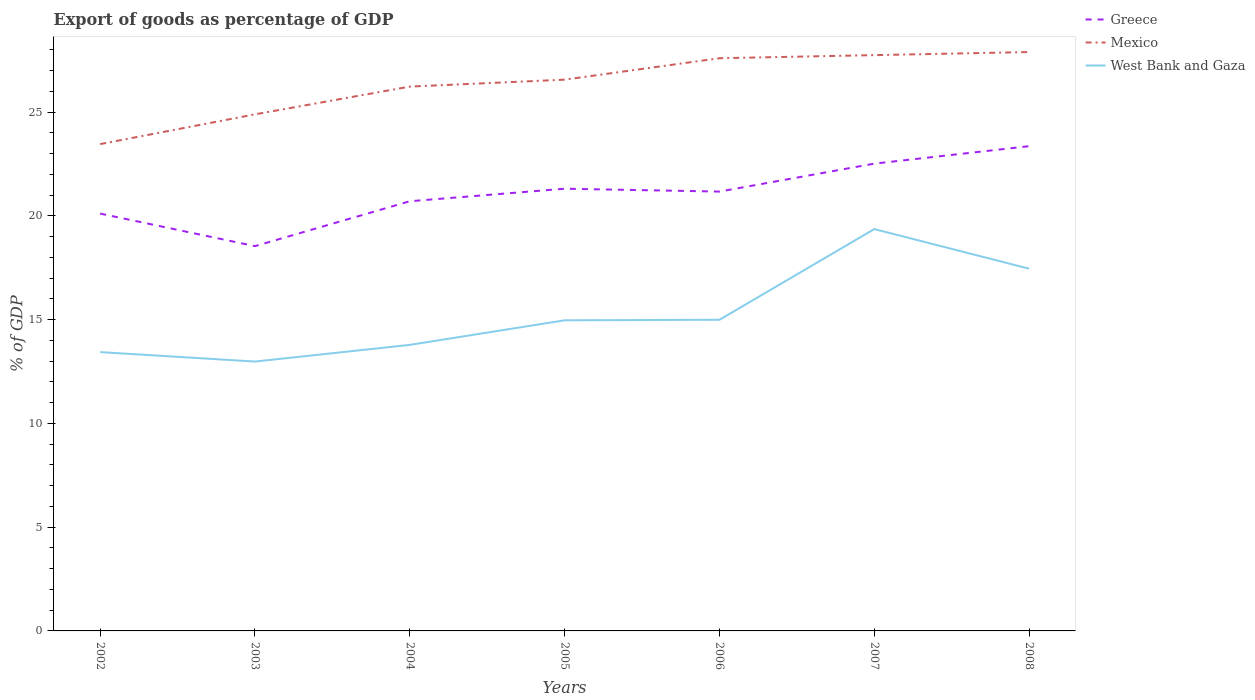How many different coloured lines are there?
Provide a succinct answer. 3. Does the line corresponding to Mexico intersect with the line corresponding to Greece?
Offer a very short reply. No. Is the number of lines equal to the number of legend labels?
Offer a terse response. Yes. Across all years, what is the maximum export of goods as percentage of GDP in Greece?
Your answer should be compact. 18.54. What is the total export of goods as percentage of GDP in Mexico in the graph?
Keep it short and to the point. -4.44. What is the difference between the highest and the second highest export of goods as percentage of GDP in Mexico?
Your answer should be very brief. 4.44. What is the difference between the highest and the lowest export of goods as percentage of GDP in West Bank and Gaza?
Offer a very short reply. 2. Is the export of goods as percentage of GDP in West Bank and Gaza strictly greater than the export of goods as percentage of GDP in Greece over the years?
Offer a terse response. Yes. How many lines are there?
Offer a terse response. 3. What is the difference between two consecutive major ticks on the Y-axis?
Provide a short and direct response. 5. How many legend labels are there?
Offer a terse response. 3. What is the title of the graph?
Your answer should be very brief. Export of goods as percentage of GDP. Does "Uganda" appear as one of the legend labels in the graph?
Make the answer very short. No. What is the label or title of the Y-axis?
Your answer should be very brief. % of GDP. What is the % of GDP in Greece in 2002?
Ensure brevity in your answer.  20.11. What is the % of GDP in Mexico in 2002?
Your response must be concise. 23.46. What is the % of GDP in West Bank and Gaza in 2002?
Your answer should be very brief. 13.44. What is the % of GDP of Greece in 2003?
Ensure brevity in your answer.  18.54. What is the % of GDP of Mexico in 2003?
Keep it short and to the point. 24.9. What is the % of GDP of West Bank and Gaza in 2003?
Ensure brevity in your answer.  12.98. What is the % of GDP of Greece in 2004?
Keep it short and to the point. 20.71. What is the % of GDP of Mexico in 2004?
Ensure brevity in your answer.  26.23. What is the % of GDP in West Bank and Gaza in 2004?
Provide a short and direct response. 13.79. What is the % of GDP in Greece in 2005?
Keep it short and to the point. 21.31. What is the % of GDP in Mexico in 2005?
Keep it short and to the point. 26.57. What is the % of GDP of West Bank and Gaza in 2005?
Offer a very short reply. 14.97. What is the % of GDP of Greece in 2006?
Offer a very short reply. 21.17. What is the % of GDP in Mexico in 2006?
Your response must be concise. 27.6. What is the % of GDP in West Bank and Gaza in 2006?
Provide a short and direct response. 15. What is the % of GDP of Greece in 2007?
Provide a short and direct response. 22.52. What is the % of GDP of Mexico in 2007?
Make the answer very short. 27.75. What is the % of GDP in West Bank and Gaza in 2007?
Your answer should be compact. 19.37. What is the % of GDP of Greece in 2008?
Your response must be concise. 23.36. What is the % of GDP of Mexico in 2008?
Your response must be concise. 27.9. What is the % of GDP of West Bank and Gaza in 2008?
Your answer should be very brief. 17.46. Across all years, what is the maximum % of GDP of Greece?
Keep it short and to the point. 23.36. Across all years, what is the maximum % of GDP of Mexico?
Your answer should be very brief. 27.9. Across all years, what is the maximum % of GDP of West Bank and Gaza?
Your answer should be compact. 19.37. Across all years, what is the minimum % of GDP in Greece?
Your response must be concise. 18.54. Across all years, what is the minimum % of GDP in Mexico?
Provide a short and direct response. 23.46. Across all years, what is the minimum % of GDP of West Bank and Gaza?
Make the answer very short. 12.98. What is the total % of GDP in Greece in the graph?
Your response must be concise. 147.73. What is the total % of GDP in Mexico in the graph?
Give a very brief answer. 184.41. What is the total % of GDP of West Bank and Gaza in the graph?
Your response must be concise. 106.99. What is the difference between the % of GDP of Greece in 2002 and that in 2003?
Provide a succinct answer. 1.57. What is the difference between the % of GDP in Mexico in 2002 and that in 2003?
Your response must be concise. -1.43. What is the difference between the % of GDP of West Bank and Gaza in 2002 and that in 2003?
Offer a terse response. 0.46. What is the difference between the % of GDP in Greece in 2002 and that in 2004?
Make the answer very short. -0.6. What is the difference between the % of GDP of Mexico in 2002 and that in 2004?
Make the answer very short. -2.77. What is the difference between the % of GDP in West Bank and Gaza in 2002 and that in 2004?
Ensure brevity in your answer.  -0.35. What is the difference between the % of GDP in Greece in 2002 and that in 2005?
Your response must be concise. -1.2. What is the difference between the % of GDP of Mexico in 2002 and that in 2005?
Your answer should be compact. -3.11. What is the difference between the % of GDP in West Bank and Gaza in 2002 and that in 2005?
Keep it short and to the point. -1.53. What is the difference between the % of GDP in Greece in 2002 and that in 2006?
Your response must be concise. -1.06. What is the difference between the % of GDP of Mexico in 2002 and that in 2006?
Offer a terse response. -4.14. What is the difference between the % of GDP of West Bank and Gaza in 2002 and that in 2006?
Keep it short and to the point. -1.56. What is the difference between the % of GDP in Greece in 2002 and that in 2007?
Offer a very short reply. -2.41. What is the difference between the % of GDP in Mexico in 2002 and that in 2007?
Make the answer very short. -4.29. What is the difference between the % of GDP of West Bank and Gaza in 2002 and that in 2007?
Provide a succinct answer. -5.93. What is the difference between the % of GDP of Greece in 2002 and that in 2008?
Make the answer very short. -3.25. What is the difference between the % of GDP in Mexico in 2002 and that in 2008?
Your answer should be compact. -4.44. What is the difference between the % of GDP of West Bank and Gaza in 2002 and that in 2008?
Provide a succinct answer. -4.02. What is the difference between the % of GDP of Greece in 2003 and that in 2004?
Keep it short and to the point. -2.16. What is the difference between the % of GDP in Mexico in 2003 and that in 2004?
Provide a succinct answer. -1.34. What is the difference between the % of GDP of West Bank and Gaza in 2003 and that in 2004?
Provide a short and direct response. -0.8. What is the difference between the % of GDP in Greece in 2003 and that in 2005?
Ensure brevity in your answer.  -2.77. What is the difference between the % of GDP in Mexico in 2003 and that in 2005?
Make the answer very short. -1.67. What is the difference between the % of GDP of West Bank and Gaza in 2003 and that in 2005?
Make the answer very short. -1.99. What is the difference between the % of GDP in Greece in 2003 and that in 2006?
Provide a short and direct response. -2.63. What is the difference between the % of GDP in Mexico in 2003 and that in 2006?
Keep it short and to the point. -2.7. What is the difference between the % of GDP of West Bank and Gaza in 2003 and that in 2006?
Keep it short and to the point. -2.01. What is the difference between the % of GDP of Greece in 2003 and that in 2007?
Give a very brief answer. -3.98. What is the difference between the % of GDP of Mexico in 2003 and that in 2007?
Ensure brevity in your answer.  -2.85. What is the difference between the % of GDP of West Bank and Gaza in 2003 and that in 2007?
Offer a very short reply. -6.39. What is the difference between the % of GDP in Greece in 2003 and that in 2008?
Give a very brief answer. -4.82. What is the difference between the % of GDP of Mexico in 2003 and that in 2008?
Make the answer very short. -3. What is the difference between the % of GDP of West Bank and Gaza in 2003 and that in 2008?
Your answer should be compact. -4.48. What is the difference between the % of GDP of Greece in 2004 and that in 2005?
Your answer should be compact. -0.6. What is the difference between the % of GDP in Mexico in 2004 and that in 2005?
Your answer should be compact. -0.33. What is the difference between the % of GDP in West Bank and Gaza in 2004 and that in 2005?
Your answer should be very brief. -1.18. What is the difference between the % of GDP of Greece in 2004 and that in 2006?
Offer a very short reply. -0.47. What is the difference between the % of GDP of Mexico in 2004 and that in 2006?
Make the answer very short. -1.37. What is the difference between the % of GDP in West Bank and Gaza in 2004 and that in 2006?
Your answer should be very brief. -1.21. What is the difference between the % of GDP of Greece in 2004 and that in 2007?
Offer a very short reply. -1.81. What is the difference between the % of GDP in Mexico in 2004 and that in 2007?
Provide a succinct answer. -1.52. What is the difference between the % of GDP in West Bank and Gaza in 2004 and that in 2007?
Provide a short and direct response. -5.58. What is the difference between the % of GDP of Greece in 2004 and that in 2008?
Make the answer very short. -2.65. What is the difference between the % of GDP of Mexico in 2004 and that in 2008?
Offer a terse response. -1.66. What is the difference between the % of GDP in West Bank and Gaza in 2004 and that in 2008?
Keep it short and to the point. -3.67. What is the difference between the % of GDP of Greece in 2005 and that in 2006?
Your response must be concise. 0.14. What is the difference between the % of GDP in Mexico in 2005 and that in 2006?
Provide a succinct answer. -1.03. What is the difference between the % of GDP in West Bank and Gaza in 2005 and that in 2006?
Your response must be concise. -0.03. What is the difference between the % of GDP of Greece in 2005 and that in 2007?
Your answer should be very brief. -1.21. What is the difference between the % of GDP in Mexico in 2005 and that in 2007?
Provide a short and direct response. -1.18. What is the difference between the % of GDP of West Bank and Gaza in 2005 and that in 2007?
Keep it short and to the point. -4.4. What is the difference between the % of GDP in Greece in 2005 and that in 2008?
Offer a terse response. -2.05. What is the difference between the % of GDP in Mexico in 2005 and that in 2008?
Provide a succinct answer. -1.33. What is the difference between the % of GDP of West Bank and Gaza in 2005 and that in 2008?
Provide a short and direct response. -2.49. What is the difference between the % of GDP in Greece in 2006 and that in 2007?
Keep it short and to the point. -1.35. What is the difference between the % of GDP in Mexico in 2006 and that in 2007?
Make the answer very short. -0.15. What is the difference between the % of GDP of West Bank and Gaza in 2006 and that in 2007?
Your answer should be compact. -4.37. What is the difference between the % of GDP in Greece in 2006 and that in 2008?
Keep it short and to the point. -2.19. What is the difference between the % of GDP of Mexico in 2006 and that in 2008?
Ensure brevity in your answer.  -0.3. What is the difference between the % of GDP in West Bank and Gaza in 2006 and that in 2008?
Your response must be concise. -2.46. What is the difference between the % of GDP in Greece in 2007 and that in 2008?
Your answer should be very brief. -0.84. What is the difference between the % of GDP in Mexico in 2007 and that in 2008?
Give a very brief answer. -0.15. What is the difference between the % of GDP in West Bank and Gaza in 2007 and that in 2008?
Provide a short and direct response. 1.91. What is the difference between the % of GDP in Greece in 2002 and the % of GDP in Mexico in 2003?
Ensure brevity in your answer.  -4.78. What is the difference between the % of GDP in Greece in 2002 and the % of GDP in West Bank and Gaza in 2003?
Your answer should be very brief. 7.13. What is the difference between the % of GDP of Mexico in 2002 and the % of GDP of West Bank and Gaza in 2003?
Make the answer very short. 10.48. What is the difference between the % of GDP in Greece in 2002 and the % of GDP in Mexico in 2004?
Keep it short and to the point. -6.12. What is the difference between the % of GDP of Greece in 2002 and the % of GDP of West Bank and Gaza in 2004?
Offer a terse response. 6.33. What is the difference between the % of GDP of Mexico in 2002 and the % of GDP of West Bank and Gaza in 2004?
Provide a succinct answer. 9.68. What is the difference between the % of GDP of Greece in 2002 and the % of GDP of Mexico in 2005?
Your response must be concise. -6.45. What is the difference between the % of GDP in Greece in 2002 and the % of GDP in West Bank and Gaza in 2005?
Offer a very short reply. 5.14. What is the difference between the % of GDP in Mexico in 2002 and the % of GDP in West Bank and Gaza in 2005?
Make the answer very short. 8.49. What is the difference between the % of GDP in Greece in 2002 and the % of GDP in Mexico in 2006?
Your response must be concise. -7.49. What is the difference between the % of GDP of Greece in 2002 and the % of GDP of West Bank and Gaza in 2006?
Ensure brevity in your answer.  5.12. What is the difference between the % of GDP of Mexico in 2002 and the % of GDP of West Bank and Gaza in 2006?
Your answer should be compact. 8.47. What is the difference between the % of GDP in Greece in 2002 and the % of GDP in Mexico in 2007?
Your response must be concise. -7.64. What is the difference between the % of GDP of Greece in 2002 and the % of GDP of West Bank and Gaza in 2007?
Your response must be concise. 0.75. What is the difference between the % of GDP of Mexico in 2002 and the % of GDP of West Bank and Gaza in 2007?
Provide a succinct answer. 4.1. What is the difference between the % of GDP of Greece in 2002 and the % of GDP of Mexico in 2008?
Provide a short and direct response. -7.79. What is the difference between the % of GDP in Greece in 2002 and the % of GDP in West Bank and Gaza in 2008?
Ensure brevity in your answer.  2.66. What is the difference between the % of GDP of Mexico in 2002 and the % of GDP of West Bank and Gaza in 2008?
Provide a succinct answer. 6.01. What is the difference between the % of GDP in Greece in 2003 and the % of GDP in Mexico in 2004?
Your response must be concise. -7.69. What is the difference between the % of GDP of Greece in 2003 and the % of GDP of West Bank and Gaza in 2004?
Provide a short and direct response. 4.76. What is the difference between the % of GDP of Mexico in 2003 and the % of GDP of West Bank and Gaza in 2004?
Make the answer very short. 11.11. What is the difference between the % of GDP in Greece in 2003 and the % of GDP in Mexico in 2005?
Your response must be concise. -8.02. What is the difference between the % of GDP in Greece in 2003 and the % of GDP in West Bank and Gaza in 2005?
Make the answer very short. 3.58. What is the difference between the % of GDP of Mexico in 2003 and the % of GDP of West Bank and Gaza in 2005?
Your answer should be compact. 9.93. What is the difference between the % of GDP in Greece in 2003 and the % of GDP in Mexico in 2006?
Make the answer very short. -9.06. What is the difference between the % of GDP in Greece in 2003 and the % of GDP in West Bank and Gaza in 2006?
Provide a succinct answer. 3.55. What is the difference between the % of GDP of Mexico in 2003 and the % of GDP of West Bank and Gaza in 2006?
Offer a terse response. 9.9. What is the difference between the % of GDP of Greece in 2003 and the % of GDP of Mexico in 2007?
Keep it short and to the point. -9.21. What is the difference between the % of GDP in Greece in 2003 and the % of GDP in West Bank and Gaza in 2007?
Keep it short and to the point. -0.82. What is the difference between the % of GDP in Mexico in 2003 and the % of GDP in West Bank and Gaza in 2007?
Ensure brevity in your answer.  5.53. What is the difference between the % of GDP of Greece in 2003 and the % of GDP of Mexico in 2008?
Offer a very short reply. -9.35. What is the difference between the % of GDP in Greece in 2003 and the % of GDP in West Bank and Gaza in 2008?
Your answer should be compact. 1.09. What is the difference between the % of GDP in Mexico in 2003 and the % of GDP in West Bank and Gaza in 2008?
Make the answer very short. 7.44. What is the difference between the % of GDP of Greece in 2004 and the % of GDP of Mexico in 2005?
Give a very brief answer. -5.86. What is the difference between the % of GDP in Greece in 2004 and the % of GDP in West Bank and Gaza in 2005?
Keep it short and to the point. 5.74. What is the difference between the % of GDP of Mexico in 2004 and the % of GDP of West Bank and Gaza in 2005?
Offer a terse response. 11.26. What is the difference between the % of GDP in Greece in 2004 and the % of GDP in Mexico in 2006?
Your response must be concise. -6.89. What is the difference between the % of GDP in Greece in 2004 and the % of GDP in West Bank and Gaza in 2006?
Provide a succinct answer. 5.71. What is the difference between the % of GDP in Mexico in 2004 and the % of GDP in West Bank and Gaza in 2006?
Ensure brevity in your answer.  11.24. What is the difference between the % of GDP of Greece in 2004 and the % of GDP of Mexico in 2007?
Make the answer very short. -7.04. What is the difference between the % of GDP of Greece in 2004 and the % of GDP of West Bank and Gaza in 2007?
Provide a short and direct response. 1.34. What is the difference between the % of GDP of Mexico in 2004 and the % of GDP of West Bank and Gaza in 2007?
Offer a terse response. 6.87. What is the difference between the % of GDP of Greece in 2004 and the % of GDP of Mexico in 2008?
Ensure brevity in your answer.  -7.19. What is the difference between the % of GDP in Greece in 2004 and the % of GDP in West Bank and Gaza in 2008?
Keep it short and to the point. 3.25. What is the difference between the % of GDP of Mexico in 2004 and the % of GDP of West Bank and Gaza in 2008?
Your answer should be compact. 8.78. What is the difference between the % of GDP in Greece in 2005 and the % of GDP in Mexico in 2006?
Offer a very short reply. -6.29. What is the difference between the % of GDP in Greece in 2005 and the % of GDP in West Bank and Gaza in 2006?
Ensure brevity in your answer.  6.32. What is the difference between the % of GDP in Mexico in 2005 and the % of GDP in West Bank and Gaza in 2006?
Your answer should be very brief. 11.57. What is the difference between the % of GDP of Greece in 2005 and the % of GDP of Mexico in 2007?
Keep it short and to the point. -6.44. What is the difference between the % of GDP of Greece in 2005 and the % of GDP of West Bank and Gaza in 2007?
Offer a very short reply. 1.95. What is the difference between the % of GDP in Mexico in 2005 and the % of GDP in West Bank and Gaza in 2007?
Ensure brevity in your answer.  7.2. What is the difference between the % of GDP in Greece in 2005 and the % of GDP in Mexico in 2008?
Offer a very short reply. -6.59. What is the difference between the % of GDP of Greece in 2005 and the % of GDP of West Bank and Gaza in 2008?
Offer a terse response. 3.86. What is the difference between the % of GDP in Mexico in 2005 and the % of GDP in West Bank and Gaza in 2008?
Your response must be concise. 9.11. What is the difference between the % of GDP of Greece in 2006 and the % of GDP of Mexico in 2007?
Give a very brief answer. -6.58. What is the difference between the % of GDP in Greece in 2006 and the % of GDP in West Bank and Gaza in 2007?
Offer a terse response. 1.81. What is the difference between the % of GDP in Mexico in 2006 and the % of GDP in West Bank and Gaza in 2007?
Offer a terse response. 8.23. What is the difference between the % of GDP in Greece in 2006 and the % of GDP in Mexico in 2008?
Provide a short and direct response. -6.72. What is the difference between the % of GDP of Greece in 2006 and the % of GDP of West Bank and Gaza in 2008?
Provide a succinct answer. 3.72. What is the difference between the % of GDP in Mexico in 2006 and the % of GDP in West Bank and Gaza in 2008?
Offer a terse response. 10.14. What is the difference between the % of GDP in Greece in 2007 and the % of GDP in Mexico in 2008?
Ensure brevity in your answer.  -5.38. What is the difference between the % of GDP in Greece in 2007 and the % of GDP in West Bank and Gaza in 2008?
Make the answer very short. 5.06. What is the difference between the % of GDP in Mexico in 2007 and the % of GDP in West Bank and Gaza in 2008?
Your answer should be compact. 10.29. What is the average % of GDP in Greece per year?
Offer a very short reply. 21.1. What is the average % of GDP in Mexico per year?
Keep it short and to the point. 26.34. What is the average % of GDP of West Bank and Gaza per year?
Keep it short and to the point. 15.28. In the year 2002, what is the difference between the % of GDP of Greece and % of GDP of Mexico?
Give a very brief answer. -3.35. In the year 2002, what is the difference between the % of GDP in Greece and % of GDP in West Bank and Gaza?
Give a very brief answer. 6.68. In the year 2002, what is the difference between the % of GDP of Mexico and % of GDP of West Bank and Gaza?
Keep it short and to the point. 10.03. In the year 2003, what is the difference between the % of GDP of Greece and % of GDP of Mexico?
Provide a succinct answer. -6.35. In the year 2003, what is the difference between the % of GDP of Greece and % of GDP of West Bank and Gaza?
Your answer should be compact. 5.56. In the year 2003, what is the difference between the % of GDP in Mexico and % of GDP in West Bank and Gaza?
Keep it short and to the point. 11.91. In the year 2004, what is the difference between the % of GDP of Greece and % of GDP of Mexico?
Keep it short and to the point. -5.53. In the year 2004, what is the difference between the % of GDP in Greece and % of GDP in West Bank and Gaza?
Provide a succinct answer. 6.92. In the year 2004, what is the difference between the % of GDP in Mexico and % of GDP in West Bank and Gaza?
Offer a terse response. 12.45. In the year 2005, what is the difference between the % of GDP in Greece and % of GDP in Mexico?
Your answer should be very brief. -5.26. In the year 2005, what is the difference between the % of GDP in Greece and % of GDP in West Bank and Gaza?
Keep it short and to the point. 6.34. In the year 2005, what is the difference between the % of GDP of Mexico and % of GDP of West Bank and Gaza?
Provide a short and direct response. 11.6. In the year 2006, what is the difference between the % of GDP in Greece and % of GDP in Mexico?
Make the answer very short. -6.43. In the year 2006, what is the difference between the % of GDP in Greece and % of GDP in West Bank and Gaza?
Offer a very short reply. 6.18. In the year 2006, what is the difference between the % of GDP of Mexico and % of GDP of West Bank and Gaza?
Provide a short and direct response. 12.61. In the year 2007, what is the difference between the % of GDP in Greece and % of GDP in Mexico?
Provide a short and direct response. -5.23. In the year 2007, what is the difference between the % of GDP of Greece and % of GDP of West Bank and Gaza?
Your answer should be compact. 3.15. In the year 2007, what is the difference between the % of GDP in Mexico and % of GDP in West Bank and Gaza?
Your answer should be very brief. 8.38. In the year 2008, what is the difference between the % of GDP in Greece and % of GDP in Mexico?
Ensure brevity in your answer.  -4.54. In the year 2008, what is the difference between the % of GDP in Greece and % of GDP in West Bank and Gaza?
Your response must be concise. 5.9. In the year 2008, what is the difference between the % of GDP in Mexico and % of GDP in West Bank and Gaza?
Offer a terse response. 10.44. What is the ratio of the % of GDP in Greece in 2002 to that in 2003?
Give a very brief answer. 1.08. What is the ratio of the % of GDP in Mexico in 2002 to that in 2003?
Keep it short and to the point. 0.94. What is the ratio of the % of GDP in West Bank and Gaza in 2002 to that in 2003?
Keep it short and to the point. 1.04. What is the ratio of the % of GDP of Greece in 2002 to that in 2004?
Your answer should be compact. 0.97. What is the ratio of the % of GDP in Mexico in 2002 to that in 2004?
Give a very brief answer. 0.89. What is the ratio of the % of GDP in West Bank and Gaza in 2002 to that in 2004?
Offer a terse response. 0.97. What is the ratio of the % of GDP in Greece in 2002 to that in 2005?
Keep it short and to the point. 0.94. What is the ratio of the % of GDP of Mexico in 2002 to that in 2005?
Your response must be concise. 0.88. What is the ratio of the % of GDP of West Bank and Gaza in 2002 to that in 2005?
Keep it short and to the point. 0.9. What is the ratio of the % of GDP of Greece in 2002 to that in 2006?
Offer a very short reply. 0.95. What is the ratio of the % of GDP of Mexico in 2002 to that in 2006?
Keep it short and to the point. 0.85. What is the ratio of the % of GDP in West Bank and Gaza in 2002 to that in 2006?
Your response must be concise. 0.9. What is the ratio of the % of GDP of Greece in 2002 to that in 2007?
Keep it short and to the point. 0.89. What is the ratio of the % of GDP of Mexico in 2002 to that in 2007?
Your response must be concise. 0.85. What is the ratio of the % of GDP in West Bank and Gaza in 2002 to that in 2007?
Keep it short and to the point. 0.69. What is the ratio of the % of GDP in Greece in 2002 to that in 2008?
Keep it short and to the point. 0.86. What is the ratio of the % of GDP in Mexico in 2002 to that in 2008?
Your answer should be compact. 0.84. What is the ratio of the % of GDP in West Bank and Gaza in 2002 to that in 2008?
Your answer should be compact. 0.77. What is the ratio of the % of GDP in Greece in 2003 to that in 2004?
Keep it short and to the point. 0.9. What is the ratio of the % of GDP of Mexico in 2003 to that in 2004?
Provide a short and direct response. 0.95. What is the ratio of the % of GDP in West Bank and Gaza in 2003 to that in 2004?
Make the answer very short. 0.94. What is the ratio of the % of GDP in Greece in 2003 to that in 2005?
Provide a short and direct response. 0.87. What is the ratio of the % of GDP of Mexico in 2003 to that in 2005?
Offer a terse response. 0.94. What is the ratio of the % of GDP in West Bank and Gaza in 2003 to that in 2005?
Your answer should be compact. 0.87. What is the ratio of the % of GDP in Greece in 2003 to that in 2006?
Your answer should be compact. 0.88. What is the ratio of the % of GDP of Mexico in 2003 to that in 2006?
Your answer should be compact. 0.9. What is the ratio of the % of GDP in West Bank and Gaza in 2003 to that in 2006?
Provide a short and direct response. 0.87. What is the ratio of the % of GDP in Greece in 2003 to that in 2007?
Your answer should be compact. 0.82. What is the ratio of the % of GDP in Mexico in 2003 to that in 2007?
Your answer should be compact. 0.9. What is the ratio of the % of GDP of West Bank and Gaza in 2003 to that in 2007?
Give a very brief answer. 0.67. What is the ratio of the % of GDP in Greece in 2003 to that in 2008?
Offer a terse response. 0.79. What is the ratio of the % of GDP in Mexico in 2003 to that in 2008?
Your answer should be very brief. 0.89. What is the ratio of the % of GDP of West Bank and Gaza in 2003 to that in 2008?
Offer a very short reply. 0.74. What is the ratio of the % of GDP of Greece in 2004 to that in 2005?
Give a very brief answer. 0.97. What is the ratio of the % of GDP in Mexico in 2004 to that in 2005?
Make the answer very short. 0.99. What is the ratio of the % of GDP of West Bank and Gaza in 2004 to that in 2005?
Your answer should be compact. 0.92. What is the ratio of the % of GDP of Greece in 2004 to that in 2006?
Give a very brief answer. 0.98. What is the ratio of the % of GDP of Mexico in 2004 to that in 2006?
Provide a succinct answer. 0.95. What is the ratio of the % of GDP in West Bank and Gaza in 2004 to that in 2006?
Offer a very short reply. 0.92. What is the ratio of the % of GDP in Greece in 2004 to that in 2007?
Make the answer very short. 0.92. What is the ratio of the % of GDP in Mexico in 2004 to that in 2007?
Offer a terse response. 0.95. What is the ratio of the % of GDP in West Bank and Gaza in 2004 to that in 2007?
Ensure brevity in your answer.  0.71. What is the ratio of the % of GDP in Greece in 2004 to that in 2008?
Your answer should be compact. 0.89. What is the ratio of the % of GDP in Mexico in 2004 to that in 2008?
Provide a succinct answer. 0.94. What is the ratio of the % of GDP in West Bank and Gaza in 2004 to that in 2008?
Offer a very short reply. 0.79. What is the ratio of the % of GDP of Mexico in 2005 to that in 2006?
Your answer should be compact. 0.96. What is the ratio of the % of GDP in Greece in 2005 to that in 2007?
Keep it short and to the point. 0.95. What is the ratio of the % of GDP of Mexico in 2005 to that in 2007?
Your response must be concise. 0.96. What is the ratio of the % of GDP of West Bank and Gaza in 2005 to that in 2007?
Offer a terse response. 0.77. What is the ratio of the % of GDP in Greece in 2005 to that in 2008?
Give a very brief answer. 0.91. What is the ratio of the % of GDP of Mexico in 2005 to that in 2008?
Make the answer very short. 0.95. What is the ratio of the % of GDP of West Bank and Gaza in 2005 to that in 2008?
Offer a very short reply. 0.86. What is the ratio of the % of GDP of Greece in 2006 to that in 2007?
Offer a terse response. 0.94. What is the ratio of the % of GDP in Mexico in 2006 to that in 2007?
Offer a very short reply. 0.99. What is the ratio of the % of GDP in West Bank and Gaza in 2006 to that in 2007?
Keep it short and to the point. 0.77. What is the ratio of the % of GDP of Greece in 2006 to that in 2008?
Your response must be concise. 0.91. What is the ratio of the % of GDP in Mexico in 2006 to that in 2008?
Your answer should be compact. 0.99. What is the ratio of the % of GDP of West Bank and Gaza in 2006 to that in 2008?
Your answer should be compact. 0.86. What is the ratio of the % of GDP in Mexico in 2007 to that in 2008?
Provide a short and direct response. 0.99. What is the ratio of the % of GDP of West Bank and Gaza in 2007 to that in 2008?
Your answer should be very brief. 1.11. What is the difference between the highest and the second highest % of GDP in Greece?
Keep it short and to the point. 0.84. What is the difference between the highest and the second highest % of GDP in Mexico?
Your answer should be very brief. 0.15. What is the difference between the highest and the second highest % of GDP of West Bank and Gaza?
Ensure brevity in your answer.  1.91. What is the difference between the highest and the lowest % of GDP in Greece?
Give a very brief answer. 4.82. What is the difference between the highest and the lowest % of GDP in Mexico?
Make the answer very short. 4.44. What is the difference between the highest and the lowest % of GDP in West Bank and Gaza?
Your answer should be compact. 6.39. 